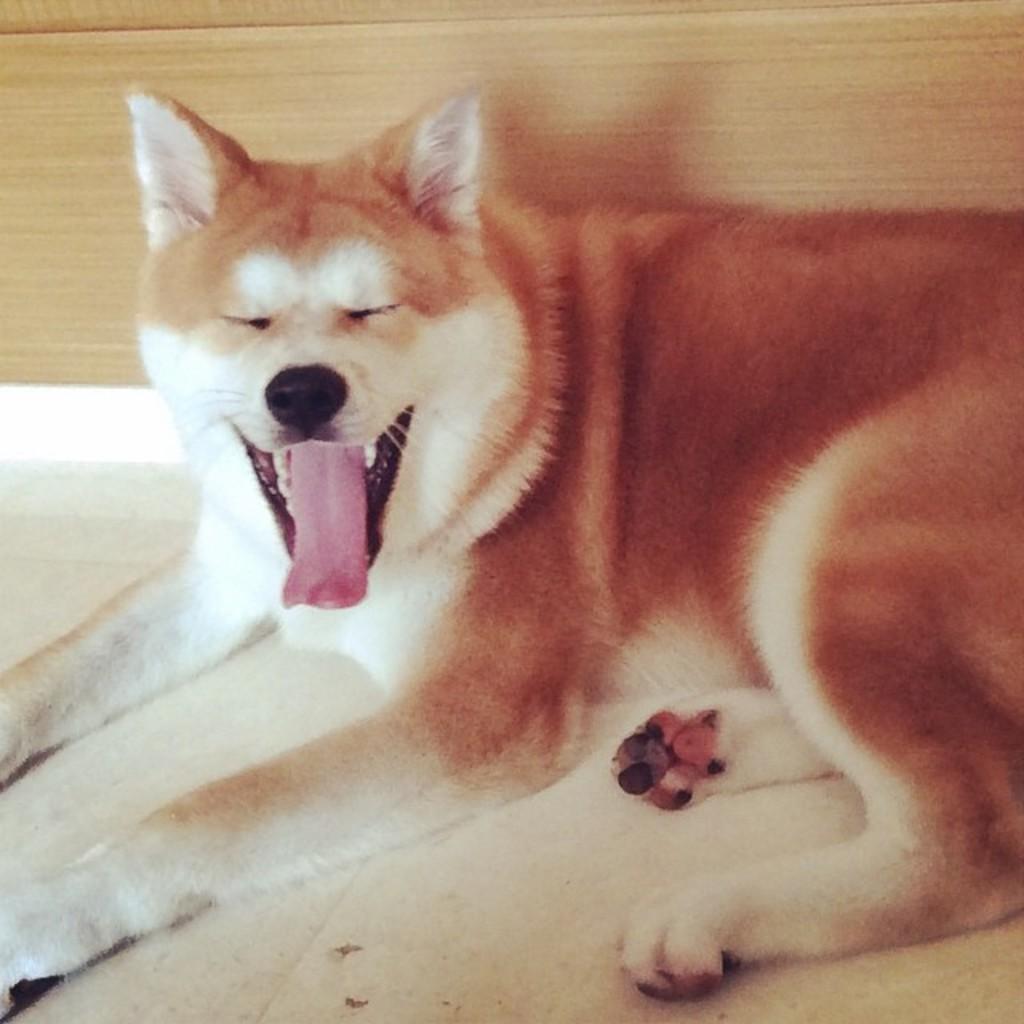Can you describe this image briefly? In this image we can see a dog on the floor. In the back there is a wooden wall. 